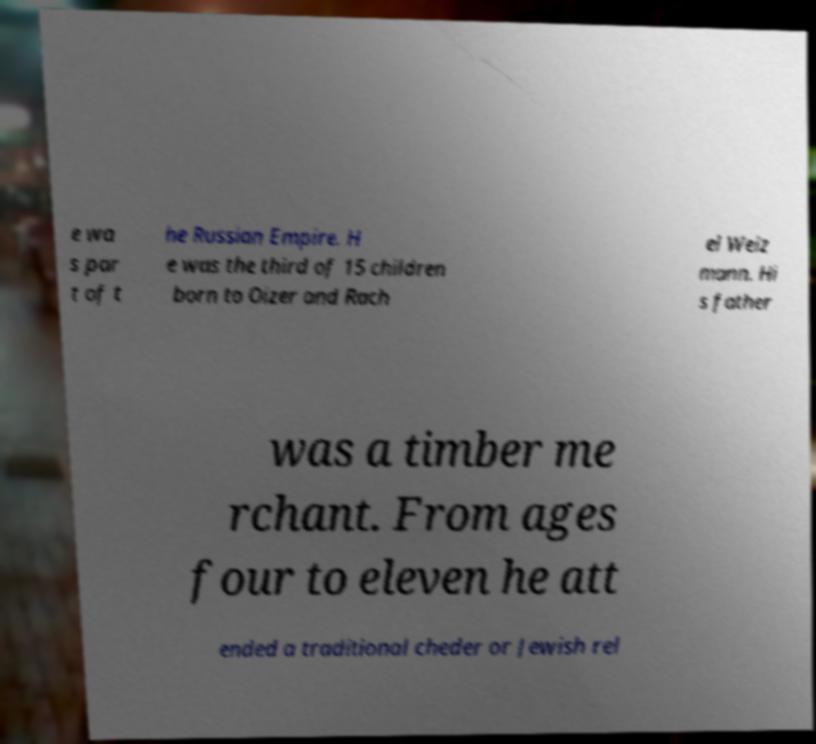Can you read and provide the text displayed in the image?This photo seems to have some interesting text. Can you extract and type it out for me? e wa s par t of t he Russian Empire. H e was the third of 15 children born to Oizer and Rach el Weiz mann. Hi s father was a timber me rchant. From ages four to eleven he att ended a traditional cheder or Jewish rel 